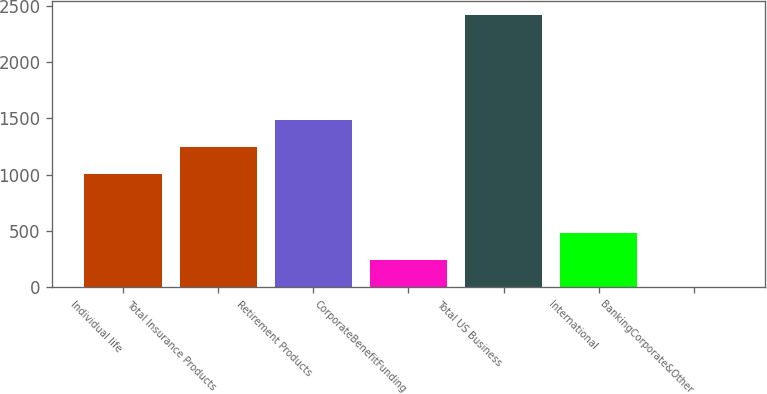Convert chart. <chart><loc_0><loc_0><loc_500><loc_500><bar_chart><fcel>Individual life<fcel>Total Insurance Products<fcel>Retirement Products<fcel>CorporateBenefitFunding<fcel>Total US Business<fcel>International<fcel>BankingCorporate&Other<nl><fcel>1005<fcel>1246.8<fcel>1488.6<fcel>242.8<fcel>2419<fcel>484.6<fcel>1<nl></chart> 